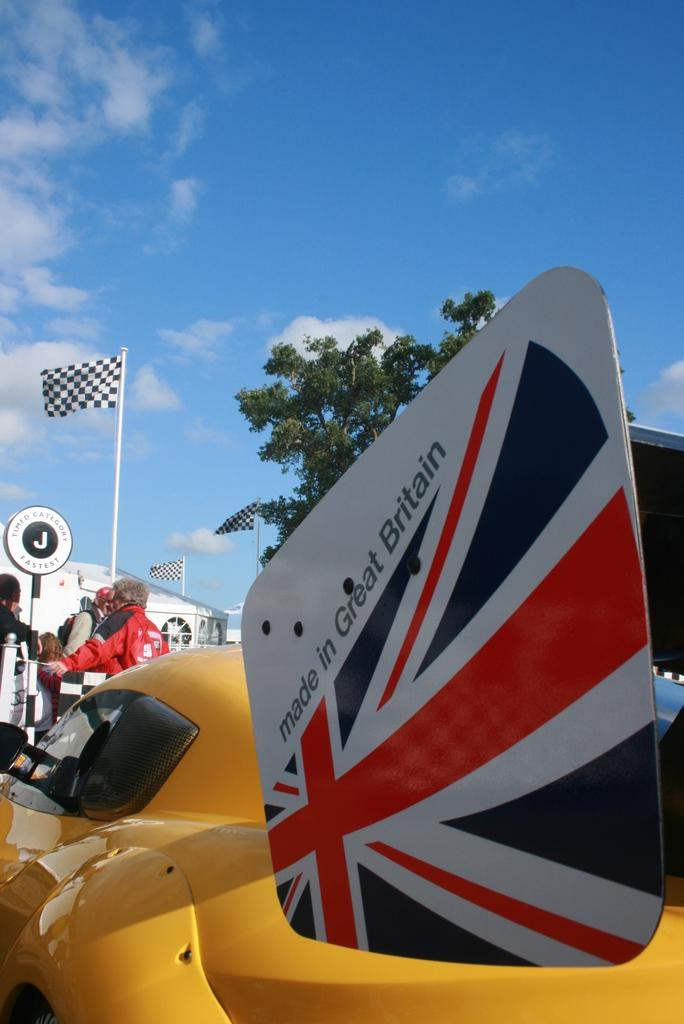<image>
Share a concise interpretation of the image provided. a Made in Great Britain sign on a yellow racing vehicle 